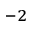<formula> <loc_0><loc_0><loc_500><loc_500>^ { - 2 }</formula> 